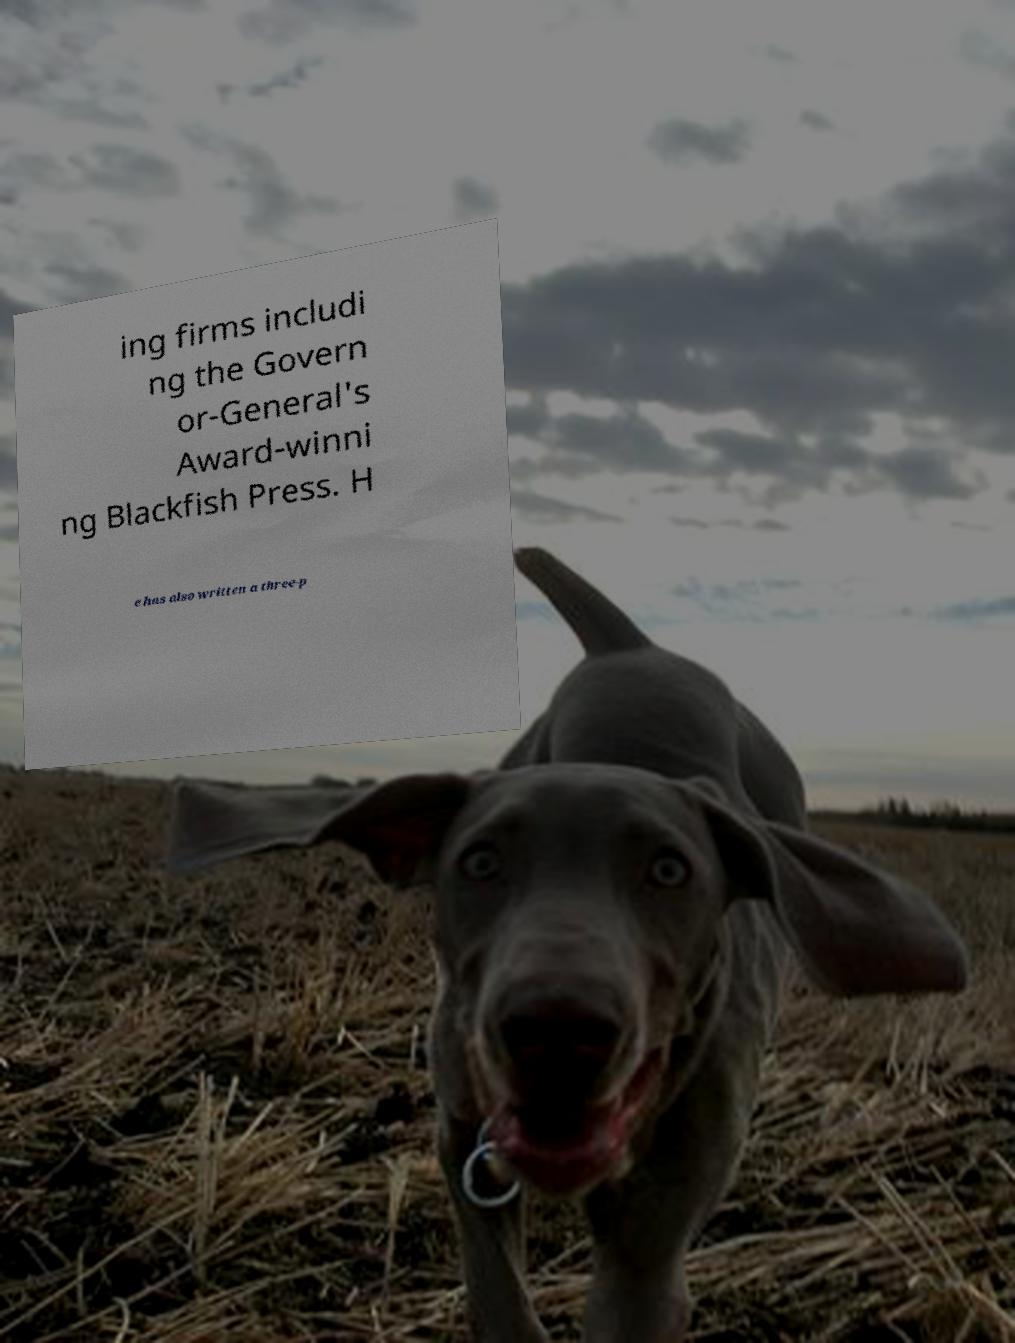Could you assist in decoding the text presented in this image and type it out clearly? ing firms includi ng the Govern or-General's Award-winni ng Blackfish Press. H e has also written a three-p 